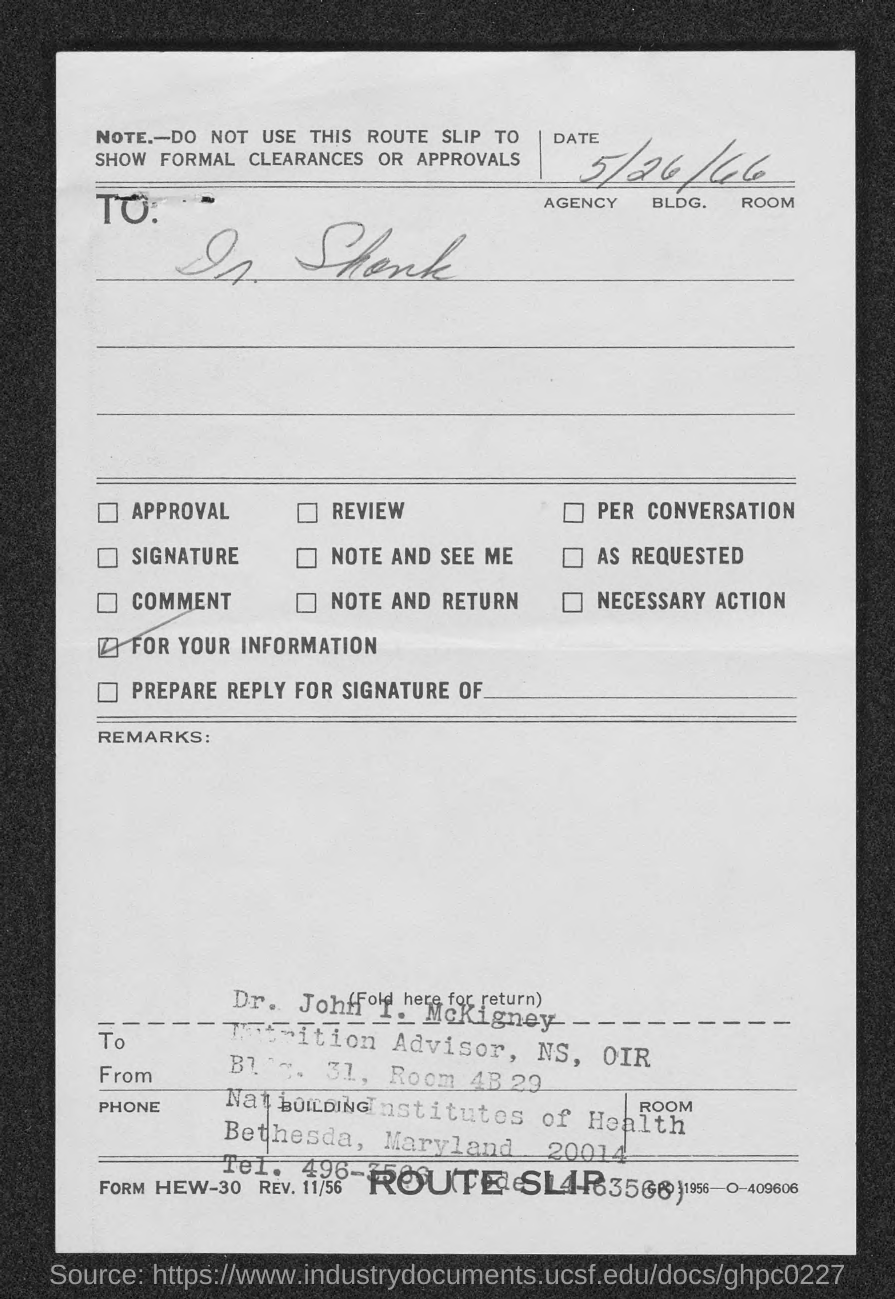What is the date mentioned in this document?
Ensure brevity in your answer.  5/26/66. What is the designation of Dr. John I. McKigney?
Offer a very short reply. Nutrition Advisor, NS, OIR. 